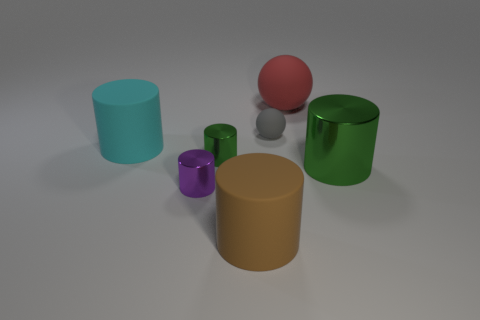How many things are either rubber balls that are on the right side of the gray ball or tiny yellow metal cubes?
Offer a very short reply. 1. What shape is the gray thing that is made of the same material as the cyan cylinder?
Offer a terse response. Sphere. What is the color of the matte object that is behind the tiny purple cylinder and in front of the gray rubber object?
Offer a very short reply. Cyan. How many cubes are cyan matte objects or large brown rubber things?
Make the answer very short. 0. How many blue metal cubes are the same size as the brown thing?
Provide a short and direct response. 0. There is a thing that is behind the small gray matte object; what number of big matte objects are left of it?
Ensure brevity in your answer.  2. How big is the cylinder that is both behind the large green cylinder and on the right side of the small purple cylinder?
Keep it short and to the point. Small. Are there more big brown rubber cylinders than blue cylinders?
Your answer should be very brief. Yes. Are there any shiny cylinders of the same color as the large metallic object?
Your answer should be compact. Yes. There is a rubber thing that is in front of the cyan matte cylinder; does it have the same size as the cyan rubber object?
Your answer should be very brief. Yes. 